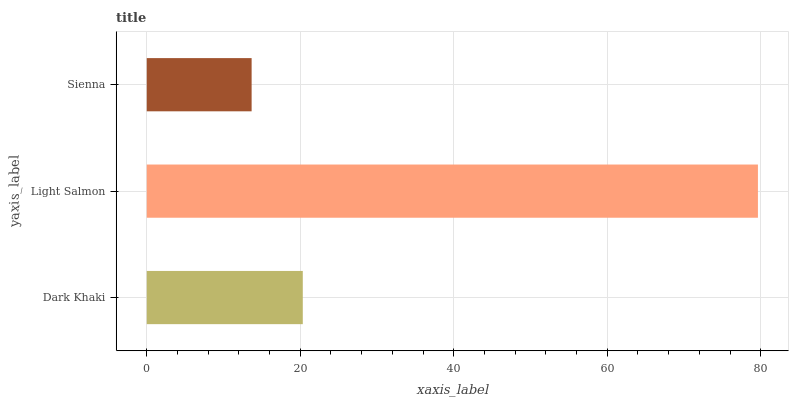Is Sienna the minimum?
Answer yes or no. Yes. Is Light Salmon the maximum?
Answer yes or no. Yes. Is Light Salmon the minimum?
Answer yes or no. No. Is Sienna the maximum?
Answer yes or no. No. Is Light Salmon greater than Sienna?
Answer yes or no. Yes. Is Sienna less than Light Salmon?
Answer yes or no. Yes. Is Sienna greater than Light Salmon?
Answer yes or no. No. Is Light Salmon less than Sienna?
Answer yes or no. No. Is Dark Khaki the high median?
Answer yes or no. Yes. Is Dark Khaki the low median?
Answer yes or no. Yes. Is Sienna the high median?
Answer yes or no. No. Is Light Salmon the low median?
Answer yes or no. No. 